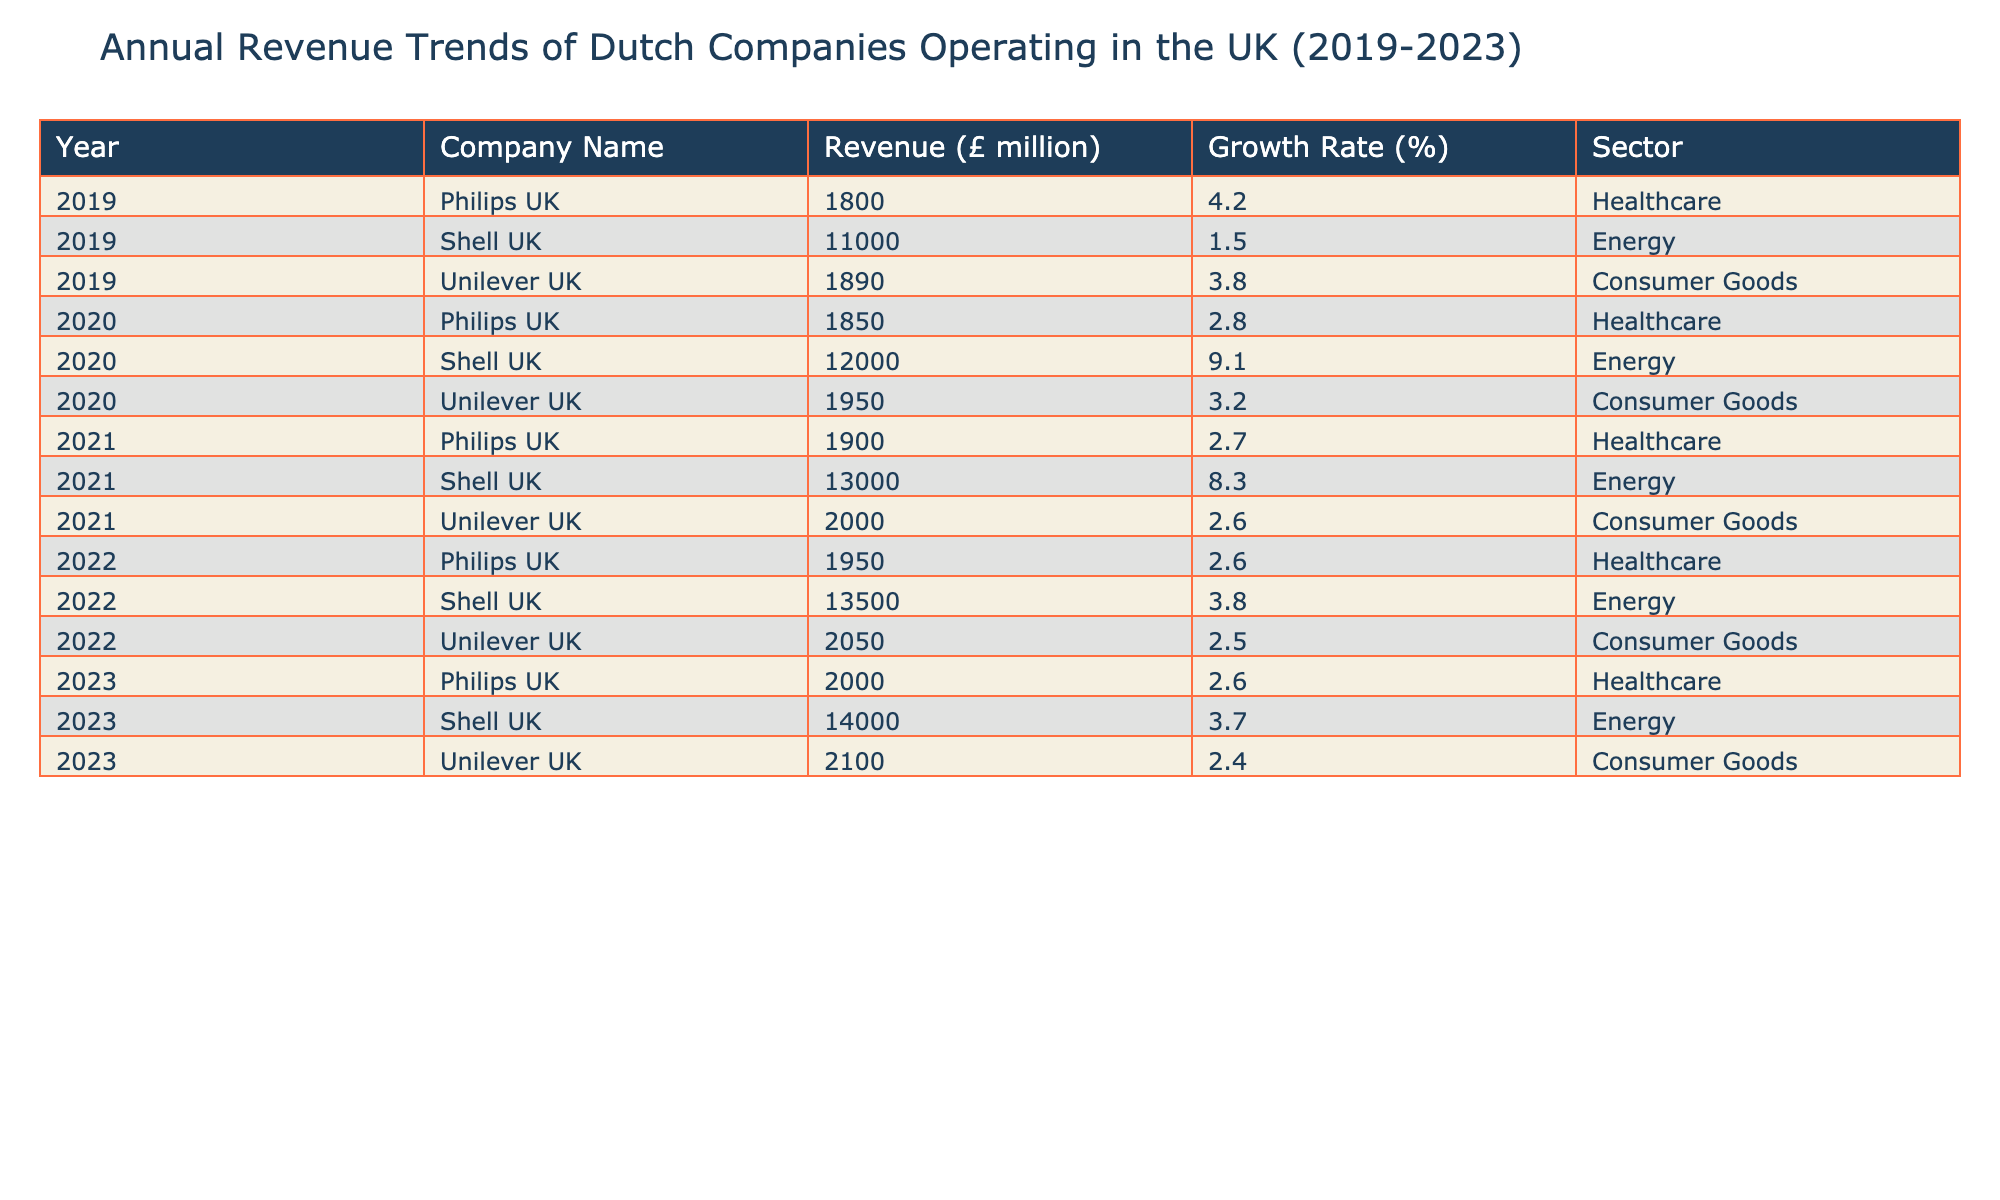What was the revenue of Shell UK in 2021? According to the table, the revenue for Shell UK in 2021 is specifically listed under that year and company name, which shows 13000 million pounds.
Answer: 13000 million pounds What was the highest revenue recorded by Philips UK over the years? By examining the revenues listed for Philips UK across the years, the highest value is found in 2019 with a revenue of 1800 million pounds.
Answer: 1800 million pounds Did Unilever UK experience growth every year from 2019 to 2023? The growth rates for Unilever UK in each year are: 2019 (3.8%), 2020 (3.2%), 2021 (2.6%), 2022 (2.5%), and 2023 (2.4%). All values are positive, indicating growth in revenue each year, although the growth rate decreased year on year.
Answer: Yes What was the average revenue for Shell UK from 2019 to 2023? The revenues for Shell UK during these years are: 11000 (2019) + 12000 (2020) + 13000 (2021) + 13500 (2022) + 14000 (2023) = 73500 million. The average is therefore 73500 divided by 5, which equals 14700 million pounds.
Answer: 14700 million pounds Which company had the highest growth rate in 2020? Reviewing the growth rates for the companies in 2020 shows Shell UK at 9.1%, which is higher than the growth rates of Philips UK (2.8%) and Unilever UK (3.2%).
Answer: Shell UK 